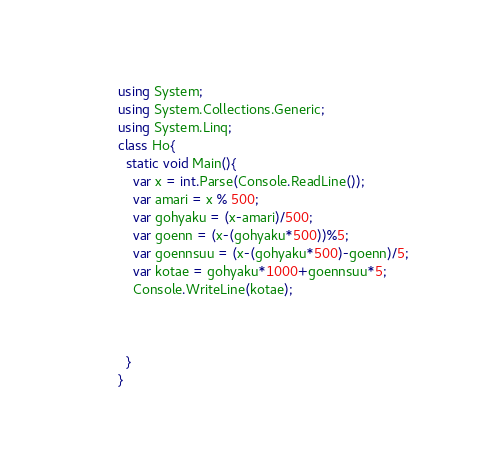Convert code to text. <code><loc_0><loc_0><loc_500><loc_500><_C#_>using System;
using System.Collections.Generic;
using System.Linq;
class Ho{
  static void Main(){
    var x = int.Parse(Console.ReadLine());
    var amari = x % 500;
    var gohyaku = (x-amari)/500;
    var goenn = (x-(gohyaku*500))%5;
    var goennsuu = (x-(gohyaku*500)-goenn)/5;
    var kotae = gohyaku*1000+goennsuu*5;
    Console.WriteLine(kotae);
    
  
      
  }
}</code> 